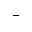<formula> <loc_0><loc_0><loc_500><loc_500>-</formula> 